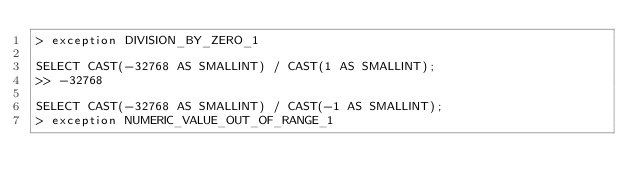Convert code to text. <code><loc_0><loc_0><loc_500><loc_500><_SQL_>> exception DIVISION_BY_ZERO_1

SELECT CAST(-32768 AS SMALLINT) / CAST(1 AS SMALLINT);
>> -32768

SELECT CAST(-32768 AS SMALLINT) / CAST(-1 AS SMALLINT);
> exception NUMERIC_VALUE_OUT_OF_RANGE_1
</code> 